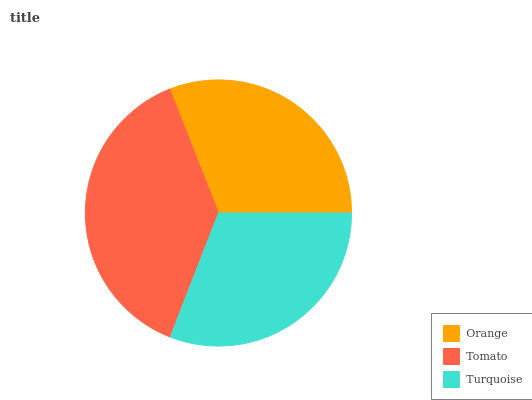Is Turquoise the minimum?
Answer yes or no. Yes. Is Tomato the maximum?
Answer yes or no. Yes. Is Tomato the minimum?
Answer yes or no. No. Is Turquoise the maximum?
Answer yes or no. No. Is Tomato greater than Turquoise?
Answer yes or no. Yes. Is Turquoise less than Tomato?
Answer yes or no. Yes. Is Turquoise greater than Tomato?
Answer yes or no. No. Is Tomato less than Turquoise?
Answer yes or no. No. Is Orange the high median?
Answer yes or no. Yes. Is Orange the low median?
Answer yes or no. Yes. Is Turquoise the high median?
Answer yes or no. No. Is Tomato the low median?
Answer yes or no. No. 